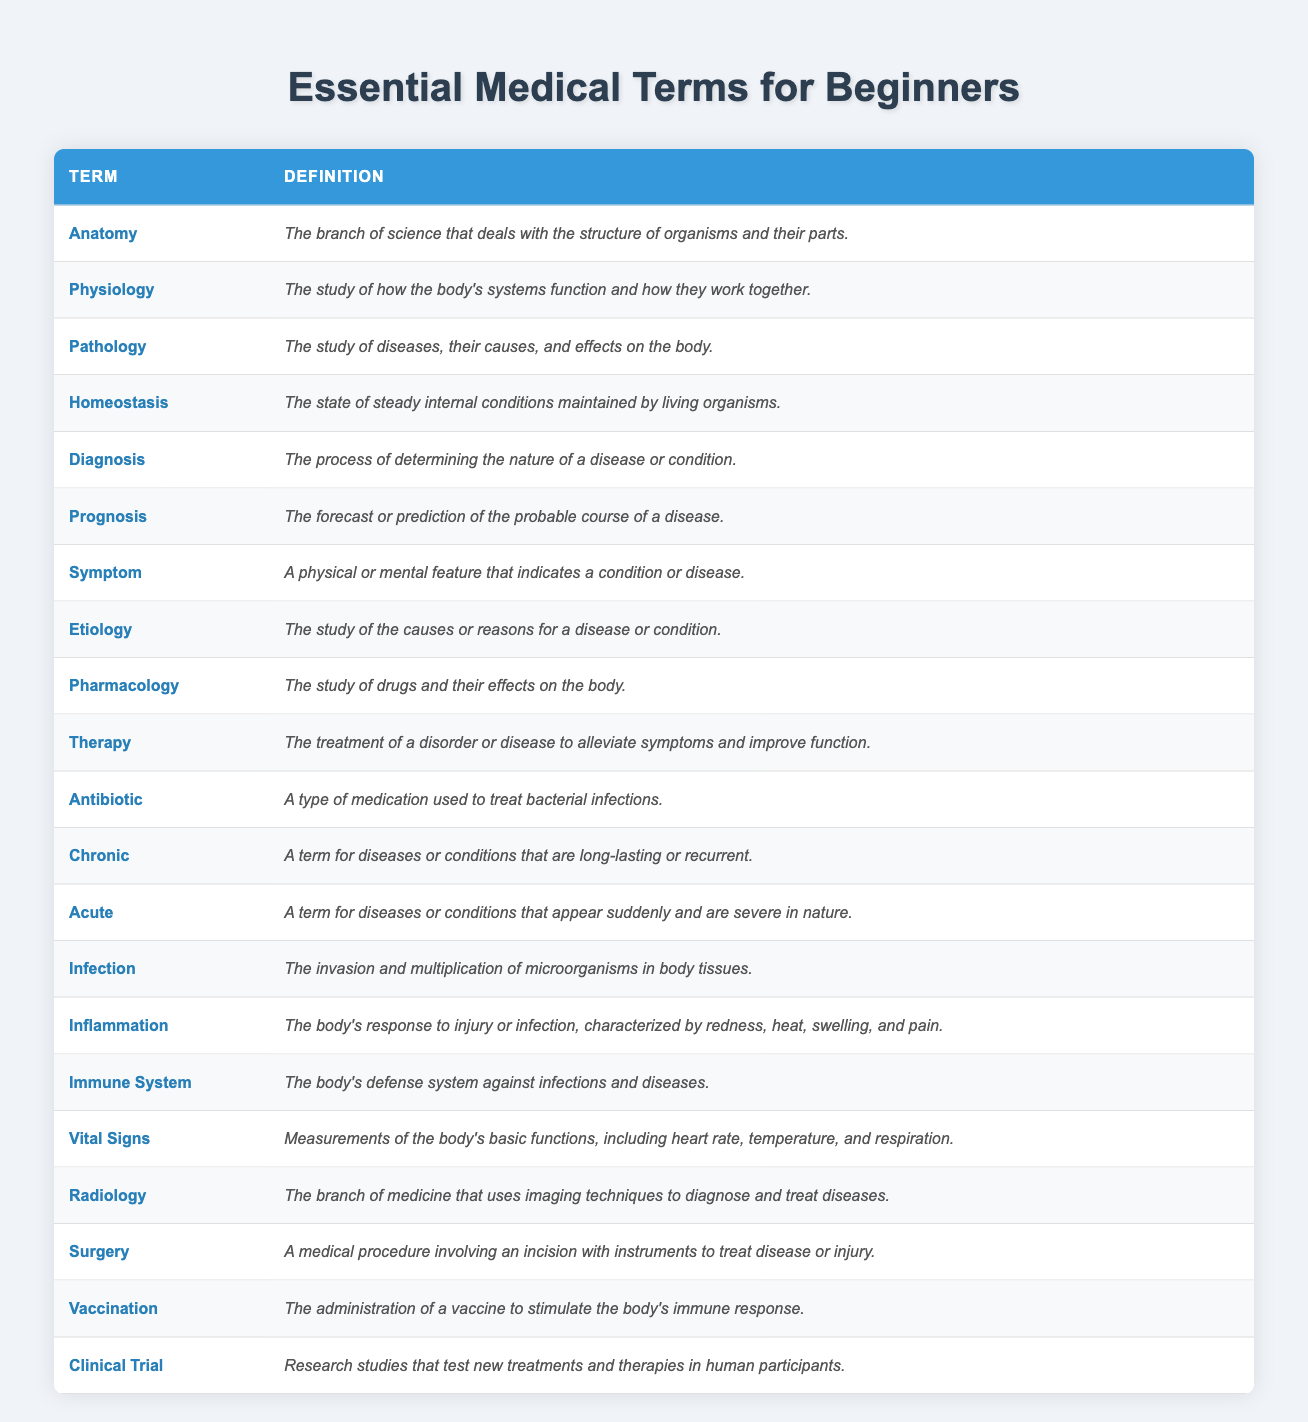What is the definition of "Pathology"? The term "Pathology" is listed in the table, where it is defined as "The study of diseases, their causes, and effects on the body." This direct retrieval of the definition provides the specific fact requested.
Answer: The study of diseases, their causes, and effects on the body How many terms are defined in the table? By counting the number of rows in the table, there are a total of 20 medical terms defined. This is a simple count of the entries in the table.
Answer: 20 Is "Chronic" defined as a term? Looking at the table, "Chronic" is indeed listed as one of the terms with its definition provided. This is a fact-based question where we simply verify if "Chronic" exists in the list.
Answer: Yes Which term indicates the body's defense system against infections? In reviewing the definitions, it is clear that the "Immune System" term is defined as the body's defense system against infections and diseases. This involves directly locating the definition for this specific term.
Answer: Immune System What are the two types of conditions described as "Acute" and "Chronic"? The table defines "Acute" as a term for diseases or conditions that appear suddenly and are severe in nature, and "Chronic" as long-lasting or recurrent diseases. This requires finding both definitions and summarizing their characteristics.
Answer: Acute: sudden and severe; Chronic: long-lasting or recurrent What is the general focus of "Pharmacology"? The table specifies that "Pharmacology" is defined as "The study of drugs and their effects on the body." Hence, it directly reflects the area of study covered by this term.
Answer: The study of drugs and their effects on the body Which term's definition mentions the word "vaccine"? From examining the definitions in the table, "Vaccination" clearly includes the word "vaccine" as it discusses the administration of a vaccine to stimulate the immune response. This requires locating the defined term and verifying its content.
Answer: Vaccination If we consider the total terms associated with bodily functions, including "Vital Signs," "Homeostasis," and "Physiology," how many terms fit that category? Reviewing those specific terms in the table, we identify that "Vital Signs," "Homeostasis," and "Physiology" focus on functions and conditions within the body. Counting these, we have three terms that fit the criteria.
Answer: 3 Which term relates to the invasion of microorganisms? In the table, "Infection" is defined specifically as "The invasion and multiplication of microorganisms in body tissues." This means locating and recognizing the definition of the relevant term.
Answer: Infection Can you summarize the difference between "Diagnosis" and "Prognosis"? The term "Diagnosis" is defined as the process of determining the nature of a disease or condition, while "Prognosis" refers to the forecast of the probable course of a disease. This involves contrasting both definitions to highlight their distinctions.
Answer: Diagnosis: determining the nature of a disease; Prognosis: forecast of disease course What are the definitions of "Therapy" and "Surgery"? "Therapy" is defined as the treatment of a disorder or disease to alleviate symptoms and improve function, while "Surgery" involves a medical procedure with an incision to treat disease or injury. This requires extracting and presenting both terms and their definitions.
Answer: Therapy: treatment to alleviate symptoms; Surgery: medical procedure involving incision 